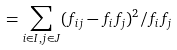Convert formula to latex. <formula><loc_0><loc_0><loc_500><loc_500>= \sum _ { i \in I , j \in J } ( f _ { i j } - f _ { i } f _ { j } ) ^ { 2 } / f _ { i } f _ { j }</formula> 